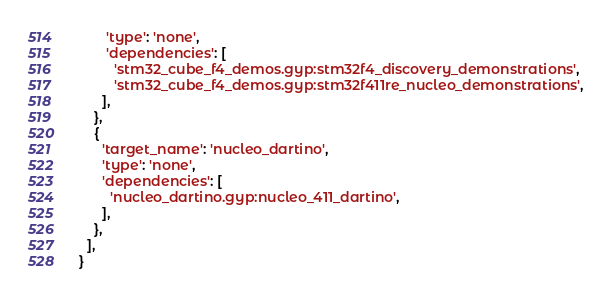<code> <loc_0><loc_0><loc_500><loc_500><_Python_>       'type': 'none',
       'dependencies': [
         'stm32_cube_f4_demos.gyp:stm32f4_discovery_demonstrations',
         'stm32_cube_f4_demos.gyp:stm32f411re_nucleo_demonstrations',
      ],
    },
    {
      'target_name': 'nucleo_dartino',
      'type': 'none',
      'dependencies': [
        'nucleo_dartino.gyp:nucleo_411_dartino',
      ],
    },
  ],
}
</code> 